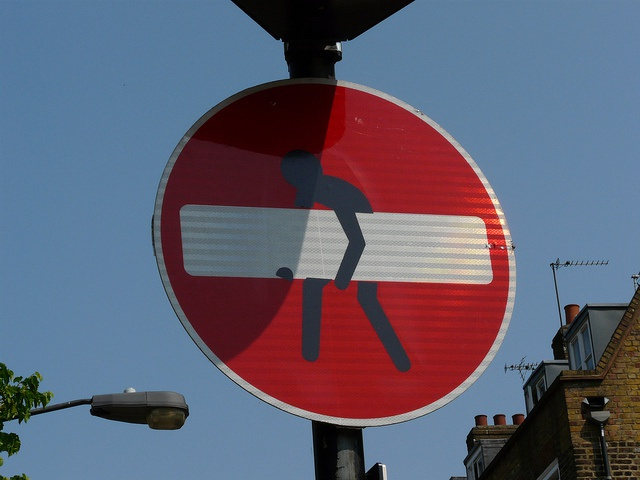Describe the objects in this image and their specific colors. I can see various objects in this image with different colors. 